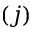<formula> <loc_0><loc_0><loc_500><loc_500>( j )</formula> 